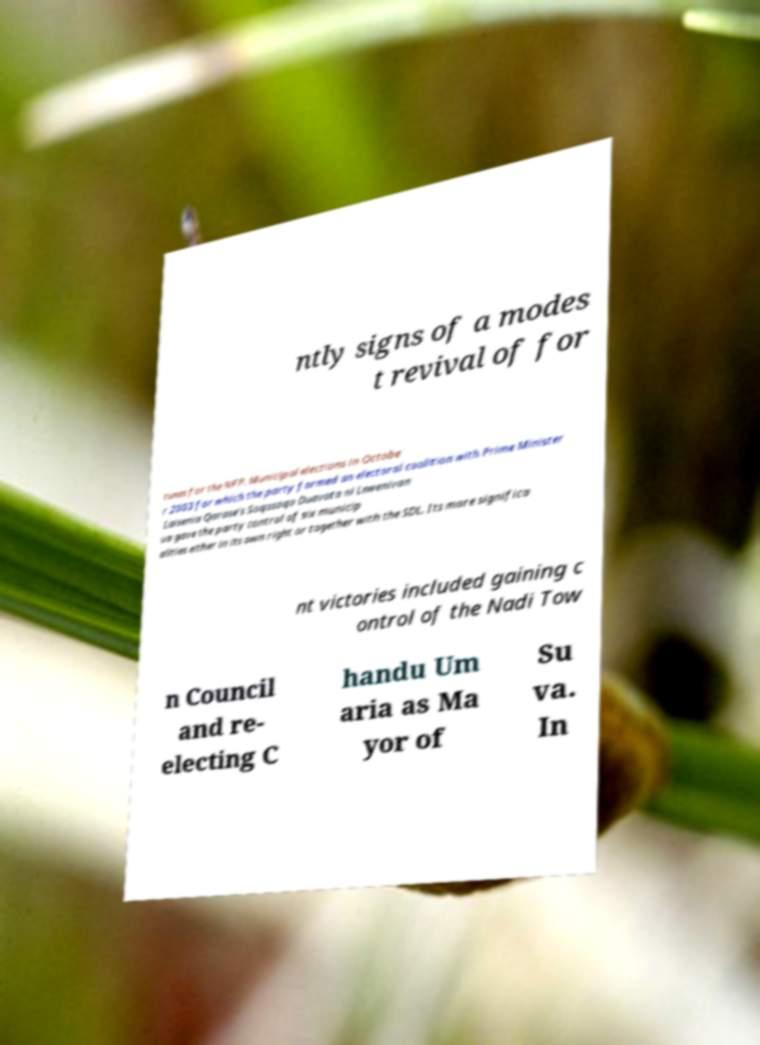Can you accurately transcribe the text from the provided image for me? ntly signs of a modes t revival of for tunes for the NFP. Municipal elections in Octobe r 2003 for which the party formed an electoral coalition with Prime Minister Laisenia Qarase's Soqosoqo Duavata ni Lewenivan ua gave the party control of six municip alities either in its own right or together with the SDL. Its more significa nt victories included gaining c ontrol of the Nadi Tow n Council and re- electing C handu Um aria as Ma yor of Su va. In 